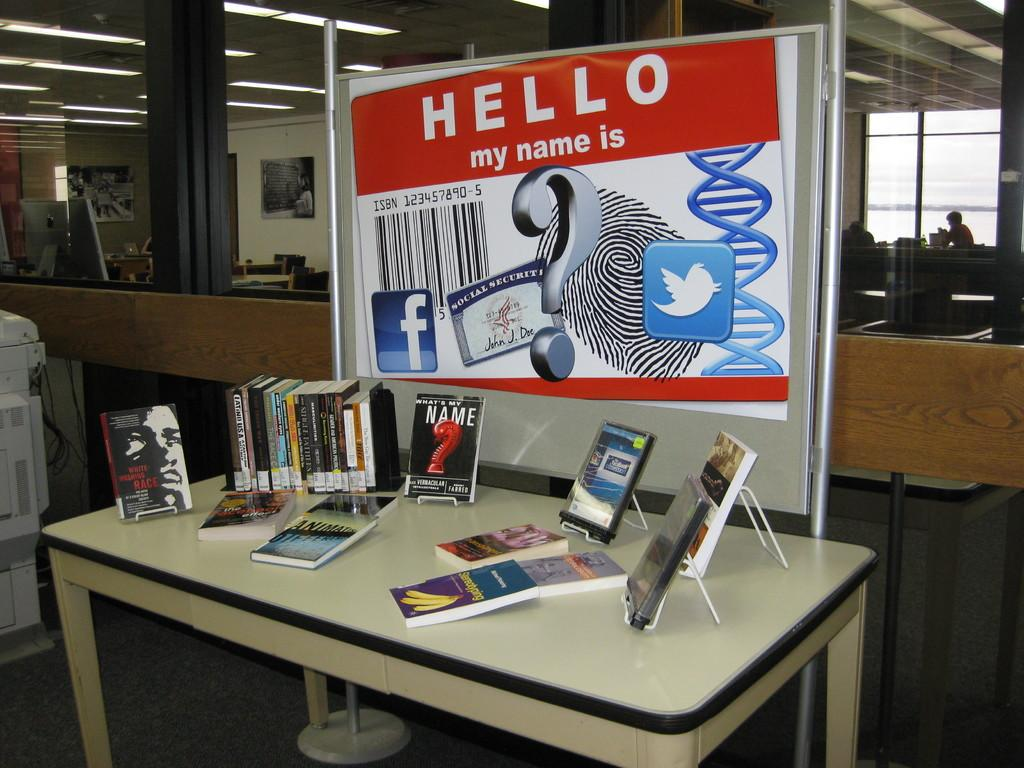<image>
Write a terse but informative summary of the picture. A big sign that says "Hello my name is" is over a table covered in books. 